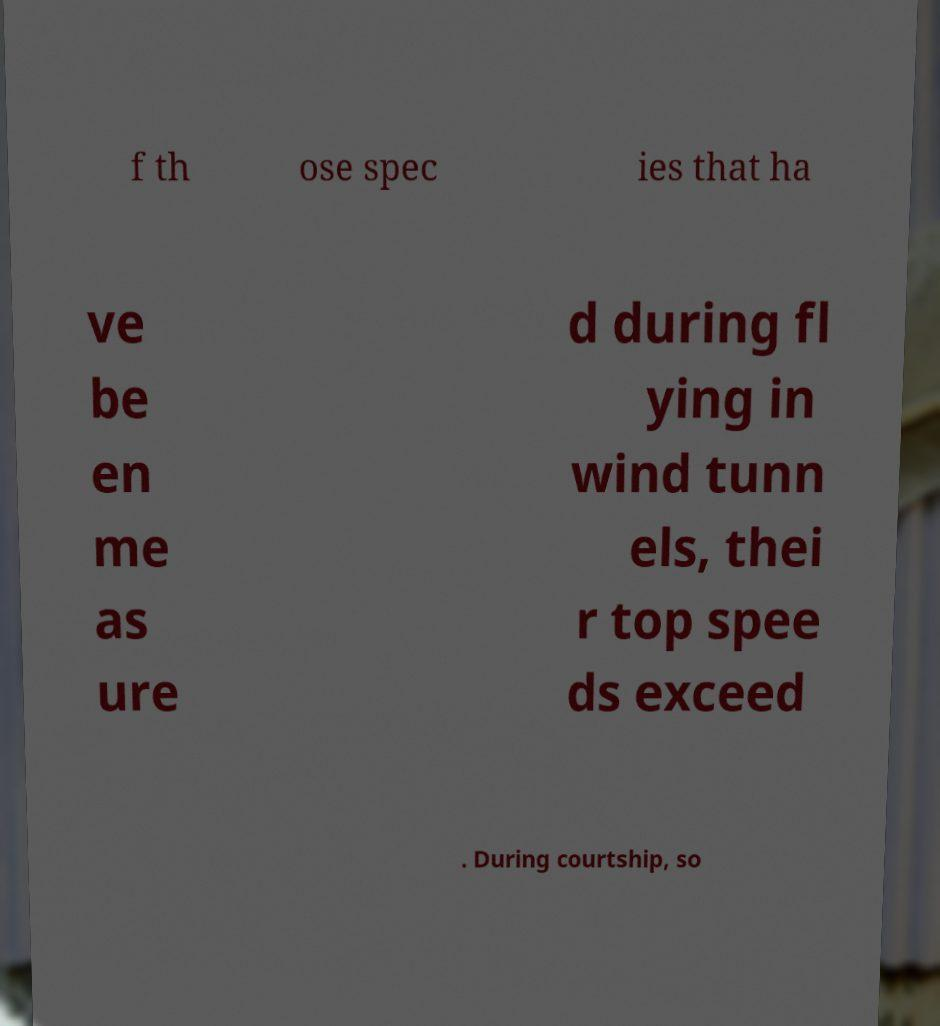Could you extract and type out the text from this image? f th ose spec ies that ha ve be en me as ure d during fl ying in wind tunn els, thei r top spee ds exceed . During courtship, so 